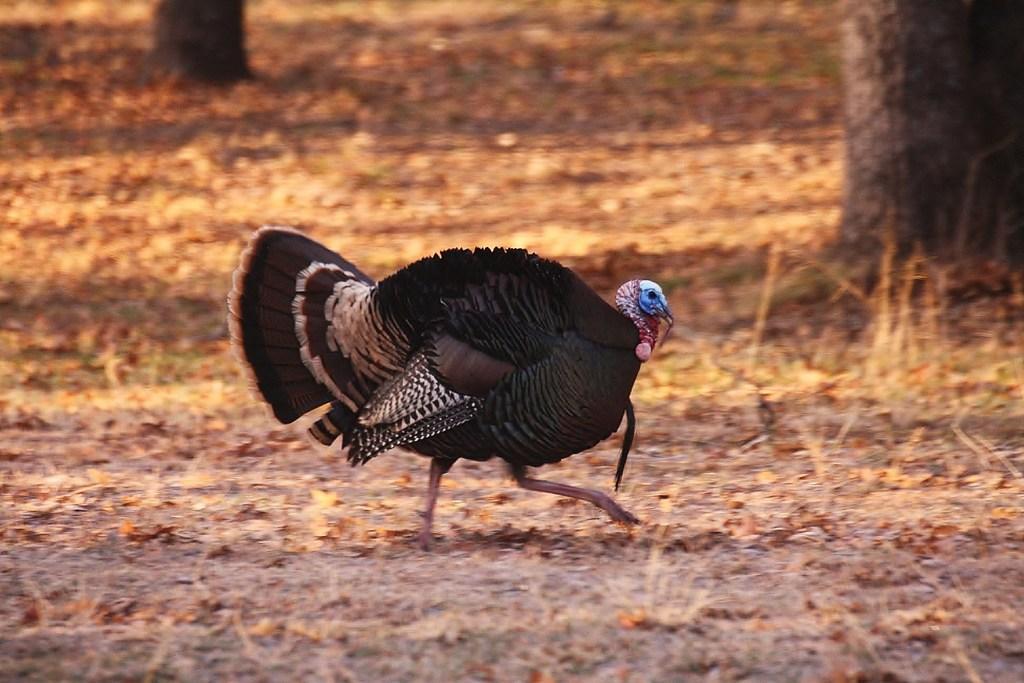How would you summarize this image in a sentence or two? In this picture there is a wild turkey bird which is walking on the ground. In the back I can see the grass and leaves. 